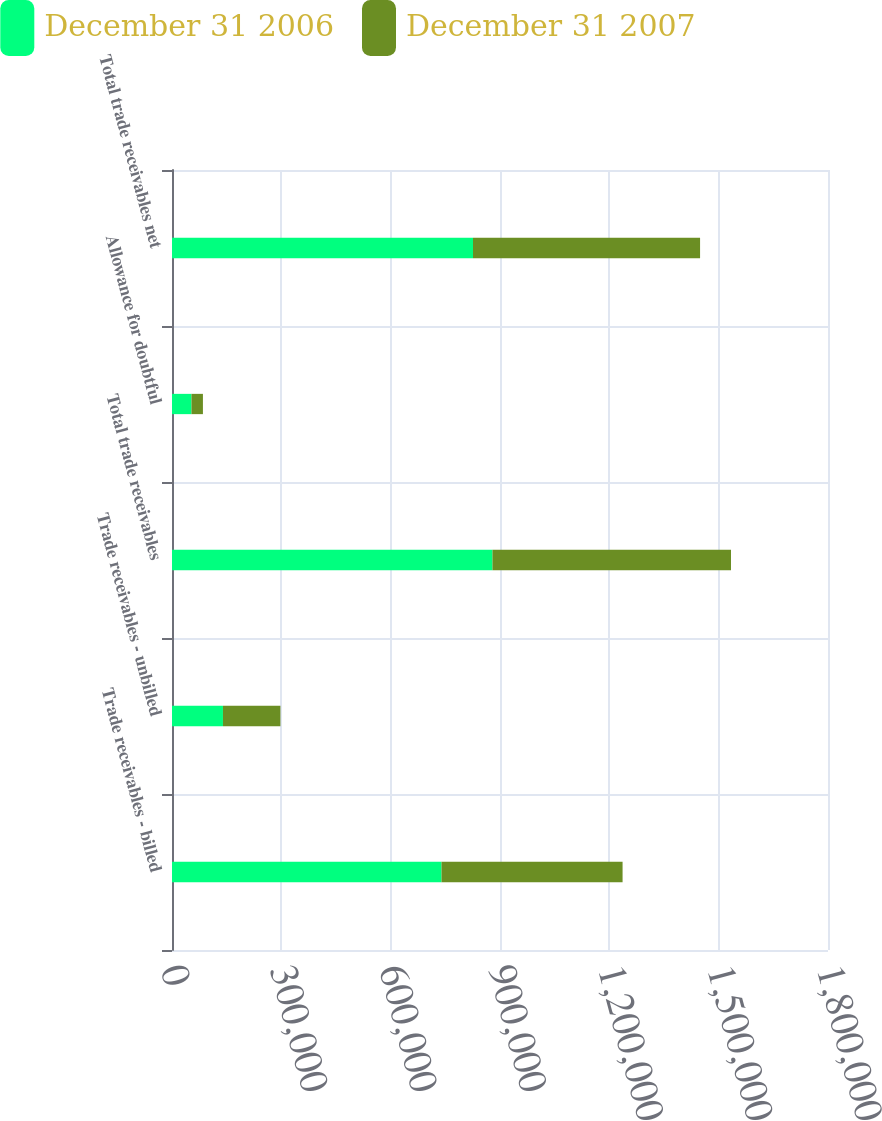Convert chart to OTSL. <chart><loc_0><loc_0><loc_500><loc_500><stacked_bar_chart><ecel><fcel>Trade receivables - billed<fcel>Trade receivables - unbilled<fcel>Total trade receivables<fcel>Allowance for doubtful<fcel>Total trade receivables net<nl><fcel>December 31 2006<fcel>739504<fcel>139815<fcel>879319<fcel>53404<fcel>825915<nl><fcel>December 31 2007<fcel>496837<fcel>157680<fcel>654517<fcel>31452<fcel>623065<nl></chart> 